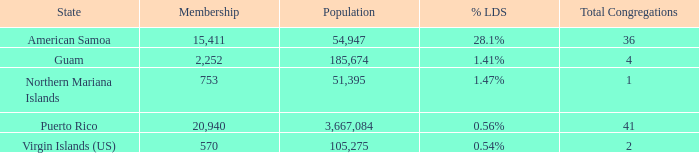What is the highest Population, when State is Puerto Rico, and when Total Congregations is greater than 41? None. 